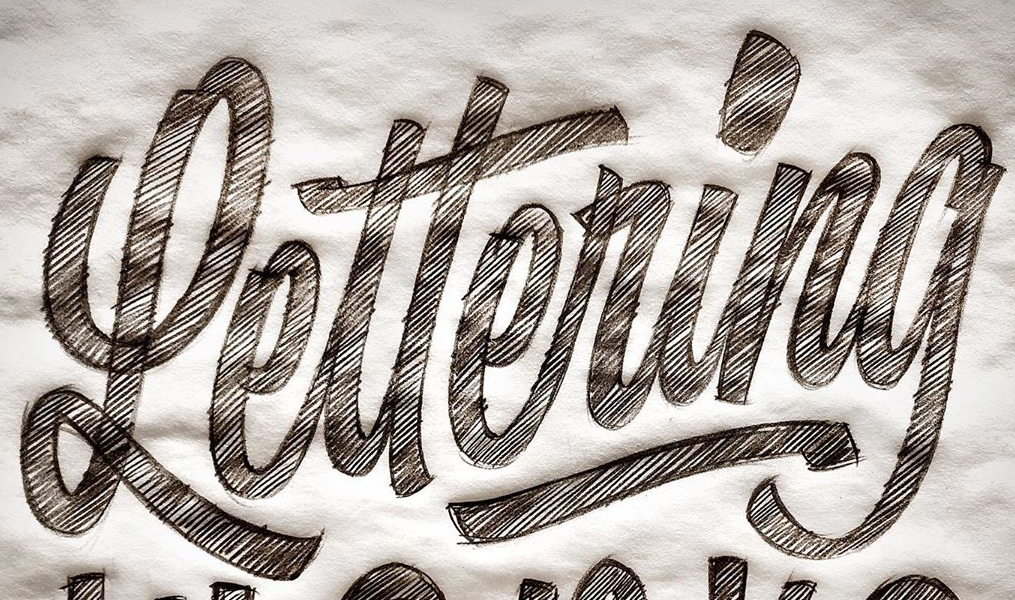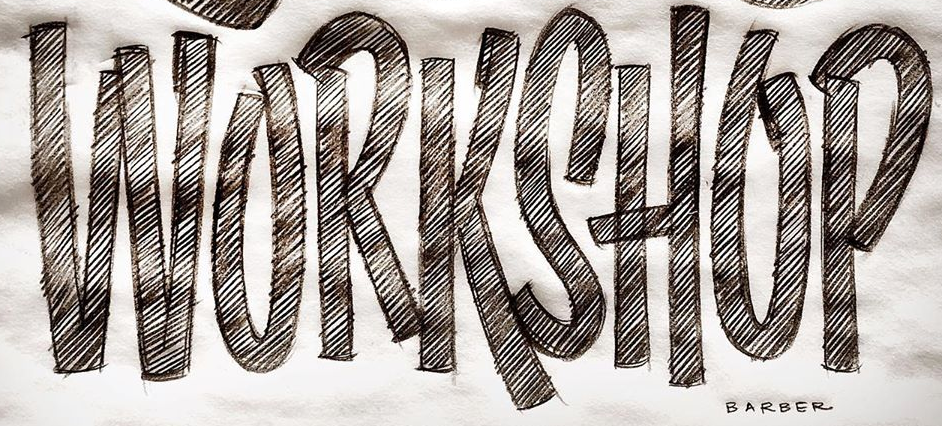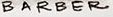Read the text content from these images in order, separated by a semicolon. Lettering; WORKSHOP; BARBER 